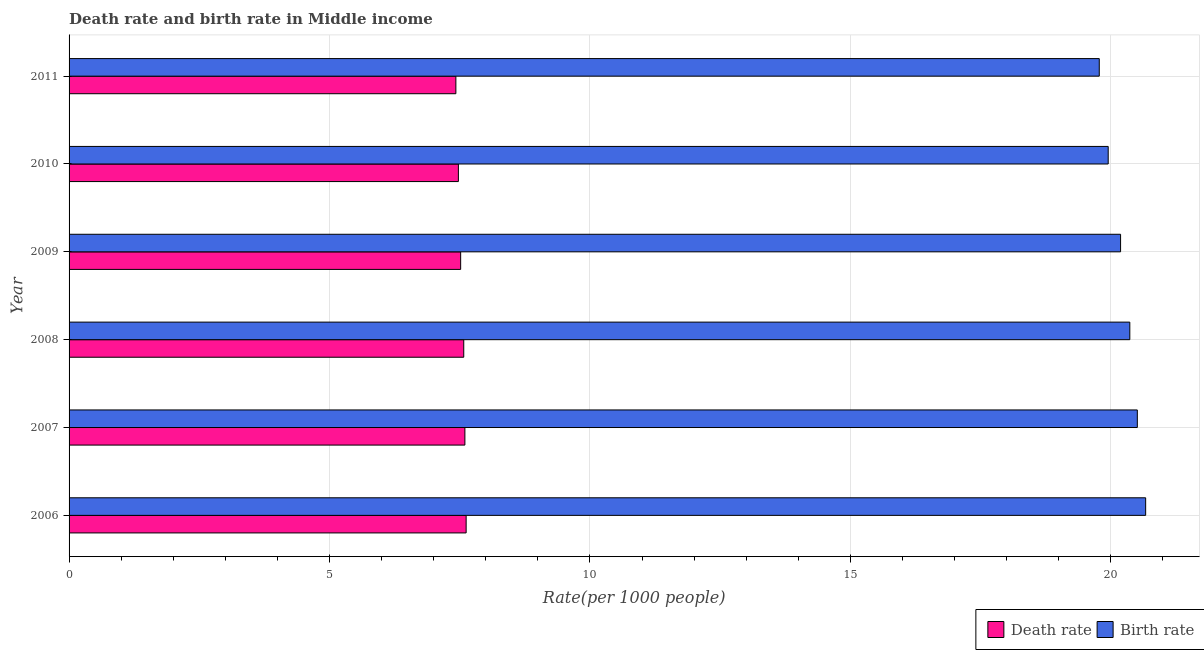How many groups of bars are there?
Your answer should be very brief. 6. Are the number of bars per tick equal to the number of legend labels?
Give a very brief answer. Yes. Are the number of bars on each tick of the Y-axis equal?
Offer a terse response. Yes. How many bars are there on the 5th tick from the top?
Provide a short and direct response. 2. How many bars are there on the 6th tick from the bottom?
Provide a succinct answer. 2. What is the label of the 6th group of bars from the top?
Your answer should be very brief. 2006. In how many cases, is the number of bars for a given year not equal to the number of legend labels?
Offer a terse response. 0. What is the death rate in 2010?
Make the answer very short. 7.47. Across all years, what is the maximum death rate?
Offer a terse response. 7.62. Across all years, what is the minimum birth rate?
Your response must be concise. 19.78. What is the total birth rate in the graph?
Provide a short and direct response. 121.46. What is the difference between the birth rate in 2008 and that in 2010?
Ensure brevity in your answer.  0.41. What is the difference between the death rate in 2008 and the birth rate in 2010?
Your answer should be compact. -12.37. What is the average birth rate per year?
Provide a short and direct response. 20.24. In the year 2007, what is the difference between the birth rate and death rate?
Keep it short and to the point. 12.91. What is the ratio of the birth rate in 2006 to that in 2009?
Provide a succinct answer. 1.02. Is the birth rate in 2006 less than that in 2011?
Your answer should be very brief. No. Is the difference between the death rate in 2007 and 2011 greater than the difference between the birth rate in 2007 and 2011?
Give a very brief answer. No. What is the difference between the highest and the second highest birth rate?
Provide a short and direct response. 0.16. What is the difference between the highest and the lowest death rate?
Provide a succinct answer. 0.2. In how many years, is the birth rate greater than the average birth rate taken over all years?
Keep it short and to the point. 3. What does the 1st bar from the top in 2009 represents?
Offer a very short reply. Birth rate. What does the 2nd bar from the bottom in 2010 represents?
Provide a succinct answer. Birth rate. How many years are there in the graph?
Provide a succinct answer. 6. Are the values on the major ticks of X-axis written in scientific E-notation?
Ensure brevity in your answer.  No. Does the graph contain any zero values?
Your response must be concise. No. How many legend labels are there?
Ensure brevity in your answer.  2. How are the legend labels stacked?
Give a very brief answer. Horizontal. What is the title of the graph?
Offer a terse response. Death rate and birth rate in Middle income. What is the label or title of the X-axis?
Offer a very short reply. Rate(per 1000 people). What is the label or title of the Y-axis?
Offer a terse response. Year. What is the Rate(per 1000 people) in Death rate in 2006?
Give a very brief answer. 7.62. What is the Rate(per 1000 people) of Birth rate in 2006?
Your answer should be very brief. 20.67. What is the Rate(per 1000 people) in Death rate in 2007?
Your answer should be compact. 7.6. What is the Rate(per 1000 people) of Birth rate in 2007?
Give a very brief answer. 20.51. What is the Rate(per 1000 people) of Death rate in 2008?
Your answer should be compact. 7.58. What is the Rate(per 1000 people) of Birth rate in 2008?
Give a very brief answer. 20.36. What is the Rate(per 1000 people) in Death rate in 2009?
Provide a succinct answer. 7.52. What is the Rate(per 1000 people) in Birth rate in 2009?
Make the answer very short. 20.19. What is the Rate(per 1000 people) of Death rate in 2010?
Make the answer very short. 7.47. What is the Rate(per 1000 people) in Birth rate in 2010?
Your answer should be very brief. 19.95. What is the Rate(per 1000 people) of Death rate in 2011?
Keep it short and to the point. 7.43. What is the Rate(per 1000 people) of Birth rate in 2011?
Offer a terse response. 19.78. Across all years, what is the maximum Rate(per 1000 people) of Death rate?
Keep it short and to the point. 7.62. Across all years, what is the maximum Rate(per 1000 people) in Birth rate?
Your answer should be compact. 20.67. Across all years, what is the minimum Rate(per 1000 people) of Death rate?
Offer a very short reply. 7.43. Across all years, what is the minimum Rate(per 1000 people) in Birth rate?
Your response must be concise. 19.78. What is the total Rate(per 1000 people) in Death rate in the graph?
Offer a terse response. 45.22. What is the total Rate(per 1000 people) in Birth rate in the graph?
Your answer should be very brief. 121.46. What is the difference between the Rate(per 1000 people) of Death rate in 2006 and that in 2007?
Provide a short and direct response. 0.02. What is the difference between the Rate(per 1000 people) in Birth rate in 2006 and that in 2007?
Provide a short and direct response. 0.16. What is the difference between the Rate(per 1000 people) of Death rate in 2006 and that in 2008?
Give a very brief answer. 0.05. What is the difference between the Rate(per 1000 people) of Birth rate in 2006 and that in 2008?
Provide a short and direct response. 0.3. What is the difference between the Rate(per 1000 people) of Death rate in 2006 and that in 2009?
Provide a short and direct response. 0.11. What is the difference between the Rate(per 1000 people) of Birth rate in 2006 and that in 2009?
Your answer should be compact. 0.48. What is the difference between the Rate(per 1000 people) of Death rate in 2006 and that in 2010?
Ensure brevity in your answer.  0.15. What is the difference between the Rate(per 1000 people) in Birth rate in 2006 and that in 2010?
Your response must be concise. 0.72. What is the difference between the Rate(per 1000 people) of Death rate in 2006 and that in 2011?
Make the answer very short. 0.2. What is the difference between the Rate(per 1000 people) of Birth rate in 2006 and that in 2011?
Offer a terse response. 0.89. What is the difference between the Rate(per 1000 people) in Death rate in 2007 and that in 2008?
Give a very brief answer. 0.02. What is the difference between the Rate(per 1000 people) in Birth rate in 2007 and that in 2008?
Provide a short and direct response. 0.14. What is the difference between the Rate(per 1000 people) in Death rate in 2007 and that in 2009?
Give a very brief answer. 0.08. What is the difference between the Rate(per 1000 people) of Birth rate in 2007 and that in 2009?
Your response must be concise. 0.32. What is the difference between the Rate(per 1000 people) of Death rate in 2007 and that in 2010?
Provide a succinct answer. 0.12. What is the difference between the Rate(per 1000 people) in Birth rate in 2007 and that in 2010?
Give a very brief answer. 0.56. What is the difference between the Rate(per 1000 people) in Death rate in 2007 and that in 2011?
Offer a terse response. 0.17. What is the difference between the Rate(per 1000 people) in Birth rate in 2007 and that in 2011?
Give a very brief answer. 0.73. What is the difference between the Rate(per 1000 people) of Death rate in 2008 and that in 2009?
Keep it short and to the point. 0.06. What is the difference between the Rate(per 1000 people) in Birth rate in 2008 and that in 2009?
Give a very brief answer. 0.18. What is the difference between the Rate(per 1000 people) of Death rate in 2008 and that in 2010?
Give a very brief answer. 0.1. What is the difference between the Rate(per 1000 people) in Birth rate in 2008 and that in 2010?
Make the answer very short. 0.41. What is the difference between the Rate(per 1000 people) of Death rate in 2008 and that in 2011?
Offer a very short reply. 0.15. What is the difference between the Rate(per 1000 people) in Birth rate in 2008 and that in 2011?
Your answer should be very brief. 0.59. What is the difference between the Rate(per 1000 people) of Death rate in 2009 and that in 2010?
Give a very brief answer. 0.04. What is the difference between the Rate(per 1000 people) in Birth rate in 2009 and that in 2010?
Offer a terse response. 0.24. What is the difference between the Rate(per 1000 people) of Death rate in 2009 and that in 2011?
Ensure brevity in your answer.  0.09. What is the difference between the Rate(per 1000 people) in Birth rate in 2009 and that in 2011?
Provide a succinct answer. 0.41. What is the difference between the Rate(per 1000 people) of Death rate in 2010 and that in 2011?
Provide a succinct answer. 0.05. What is the difference between the Rate(per 1000 people) of Birth rate in 2010 and that in 2011?
Provide a short and direct response. 0.17. What is the difference between the Rate(per 1000 people) in Death rate in 2006 and the Rate(per 1000 people) in Birth rate in 2007?
Provide a succinct answer. -12.89. What is the difference between the Rate(per 1000 people) in Death rate in 2006 and the Rate(per 1000 people) in Birth rate in 2008?
Your answer should be very brief. -12.74. What is the difference between the Rate(per 1000 people) in Death rate in 2006 and the Rate(per 1000 people) in Birth rate in 2009?
Your response must be concise. -12.56. What is the difference between the Rate(per 1000 people) in Death rate in 2006 and the Rate(per 1000 people) in Birth rate in 2010?
Your answer should be compact. -12.33. What is the difference between the Rate(per 1000 people) of Death rate in 2006 and the Rate(per 1000 people) of Birth rate in 2011?
Your answer should be compact. -12.15. What is the difference between the Rate(per 1000 people) of Death rate in 2007 and the Rate(per 1000 people) of Birth rate in 2008?
Your answer should be compact. -12.77. What is the difference between the Rate(per 1000 people) of Death rate in 2007 and the Rate(per 1000 people) of Birth rate in 2009?
Ensure brevity in your answer.  -12.59. What is the difference between the Rate(per 1000 people) in Death rate in 2007 and the Rate(per 1000 people) in Birth rate in 2010?
Offer a very short reply. -12.35. What is the difference between the Rate(per 1000 people) of Death rate in 2007 and the Rate(per 1000 people) of Birth rate in 2011?
Offer a very short reply. -12.18. What is the difference between the Rate(per 1000 people) of Death rate in 2008 and the Rate(per 1000 people) of Birth rate in 2009?
Make the answer very short. -12.61. What is the difference between the Rate(per 1000 people) in Death rate in 2008 and the Rate(per 1000 people) in Birth rate in 2010?
Make the answer very short. -12.37. What is the difference between the Rate(per 1000 people) in Death rate in 2008 and the Rate(per 1000 people) in Birth rate in 2011?
Your answer should be compact. -12.2. What is the difference between the Rate(per 1000 people) in Death rate in 2009 and the Rate(per 1000 people) in Birth rate in 2010?
Provide a short and direct response. -12.43. What is the difference between the Rate(per 1000 people) of Death rate in 2009 and the Rate(per 1000 people) of Birth rate in 2011?
Your answer should be compact. -12.26. What is the difference between the Rate(per 1000 people) in Death rate in 2010 and the Rate(per 1000 people) in Birth rate in 2011?
Provide a short and direct response. -12.3. What is the average Rate(per 1000 people) in Death rate per year?
Keep it short and to the point. 7.54. What is the average Rate(per 1000 people) of Birth rate per year?
Provide a short and direct response. 20.24. In the year 2006, what is the difference between the Rate(per 1000 people) of Death rate and Rate(per 1000 people) of Birth rate?
Ensure brevity in your answer.  -13.05. In the year 2007, what is the difference between the Rate(per 1000 people) of Death rate and Rate(per 1000 people) of Birth rate?
Your answer should be very brief. -12.91. In the year 2008, what is the difference between the Rate(per 1000 people) in Death rate and Rate(per 1000 people) in Birth rate?
Ensure brevity in your answer.  -12.79. In the year 2009, what is the difference between the Rate(per 1000 people) of Death rate and Rate(per 1000 people) of Birth rate?
Offer a terse response. -12.67. In the year 2010, what is the difference between the Rate(per 1000 people) in Death rate and Rate(per 1000 people) in Birth rate?
Provide a short and direct response. -12.48. In the year 2011, what is the difference between the Rate(per 1000 people) in Death rate and Rate(per 1000 people) in Birth rate?
Offer a terse response. -12.35. What is the ratio of the Rate(per 1000 people) of Death rate in 2006 to that in 2007?
Your response must be concise. 1. What is the ratio of the Rate(per 1000 people) of Birth rate in 2006 to that in 2007?
Offer a very short reply. 1.01. What is the ratio of the Rate(per 1000 people) in Birth rate in 2006 to that in 2008?
Provide a succinct answer. 1.01. What is the ratio of the Rate(per 1000 people) in Death rate in 2006 to that in 2009?
Keep it short and to the point. 1.01. What is the ratio of the Rate(per 1000 people) in Birth rate in 2006 to that in 2009?
Offer a terse response. 1.02. What is the ratio of the Rate(per 1000 people) in Death rate in 2006 to that in 2010?
Ensure brevity in your answer.  1.02. What is the ratio of the Rate(per 1000 people) of Birth rate in 2006 to that in 2010?
Offer a terse response. 1.04. What is the ratio of the Rate(per 1000 people) in Death rate in 2006 to that in 2011?
Offer a terse response. 1.03. What is the ratio of the Rate(per 1000 people) of Birth rate in 2006 to that in 2011?
Your answer should be very brief. 1.04. What is the ratio of the Rate(per 1000 people) in Birth rate in 2007 to that in 2008?
Give a very brief answer. 1.01. What is the ratio of the Rate(per 1000 people) of Death rate in 2007 to that in 2009?
Make the answer very short. 1.01. What is the ratio of the Rate(per 1000 people) in Birth rate in 2007 to that in 2009?
Make the answer very short. 1.02. What is the ratio of the Rate(per 1000 people) in Death rate in 2007 to that in 2010?
Your response must be concise. 1.02. What is the ratio of the Rate(per 1000 people) of Birth rate in 2007 to that in 2010?
Give a very brief answer. 1.03. What is the ratio of the Rate(per 1000 people) in Death rate in 2007 to that in 2011?
Make the answer very short. 1.02. What is the ratio of the Rate(per 1000 people) in Death rate in 2008 to that in 2009?
Give a very brief answer. 1.01. What is the ratio of the Rate(per 1000 people) of Birth rate in 2008 to that in 2009?
Give a very brief answer. 1.01. What is the ratio of the Rate(per 1000 people) of Death rate in 2008 to that in 2010?
Offer a terse response. 1.01. What is the ratio of the Rate(per 1000 people) in Birth rate in 2008 to that in 2010?
Your response must be concise. 1.02. What is the ratio of the Rate(per 1000 people) of Death rate in 2008 to that in 2011?
Give a very brief answer. 1.02. What is the ratio of the Rate(per 1000 people) in Birth rate in 2008 to that in 2011?
Your response must be concise. 1.03. What is the ratio of the Rate(per 1000 people) of Death rate in 2009 to that in 2010?
Make the answer very short. 1.01. What is the ratio of the Rate(per 1000 people) in Birth rate in 2009 to that in 2010?
Offer a terse response. 1.01. What is the ratio of the Rate(per 1000 people) in Death rate in 2009 to that in 2011?
Your answer should be compact. 1.01. What is the ratio of the Rate(per 1000 people) of Birth rate in 2009 to that in 2011?
Keep it short and to the point. 1.02. What is the ratio of the Rate(per 1000 people) of Birth rate in 2010 to that in 2011?
Offer a terse response. 1.01. What is the difference between the highest and the second highest Rate(per 1000 people) in Death rate?
Offer a terse response. 0.02. What is the difference between the highest and the second highest Rate(per 1000 people) in Birth rate?
Provide a short and direct response. 0.16. What is the difference between the highest and the lowest Rate(per 1000 people) of Death rate?
Offer a terse response. 0.2. What is the difference between the highest and the lowest Rate(per 1000 people) in Birth rate?
Make the answer very short. 0.89. 